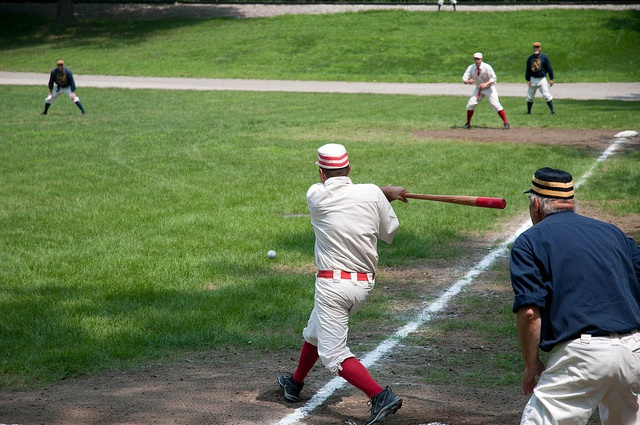Describe the objects in this image and their specific colors. I can see people in black, navy, gray, and lightgray tones, people in black, lightgray, darkgray, and gray tones, people in black, white, darkgray, and gray tones, people in black, green, gray, and darkgray tones, and people in black, gray, lightgray, and darkgray tones in this image. 